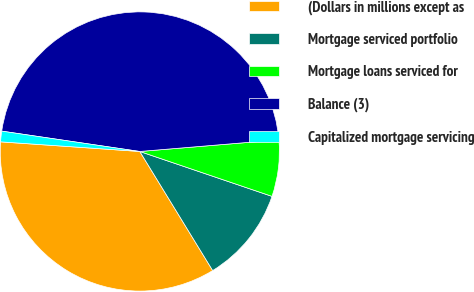<chart> <loc_0><loc_0><loc_500><loc_500><pie_chart><fcel>(Dollars in millions except as<fcel>Mortgage serviced portfolio<fcel>Mortgage loans serviced for<fcel>Balance (3)<fcel>Capitalized mortgage servicing<nl><fcel>34.84%<fcel>11.05%<fcel>6.54%<fcel>46.34%<fcel>1.23%<nl></chart> 